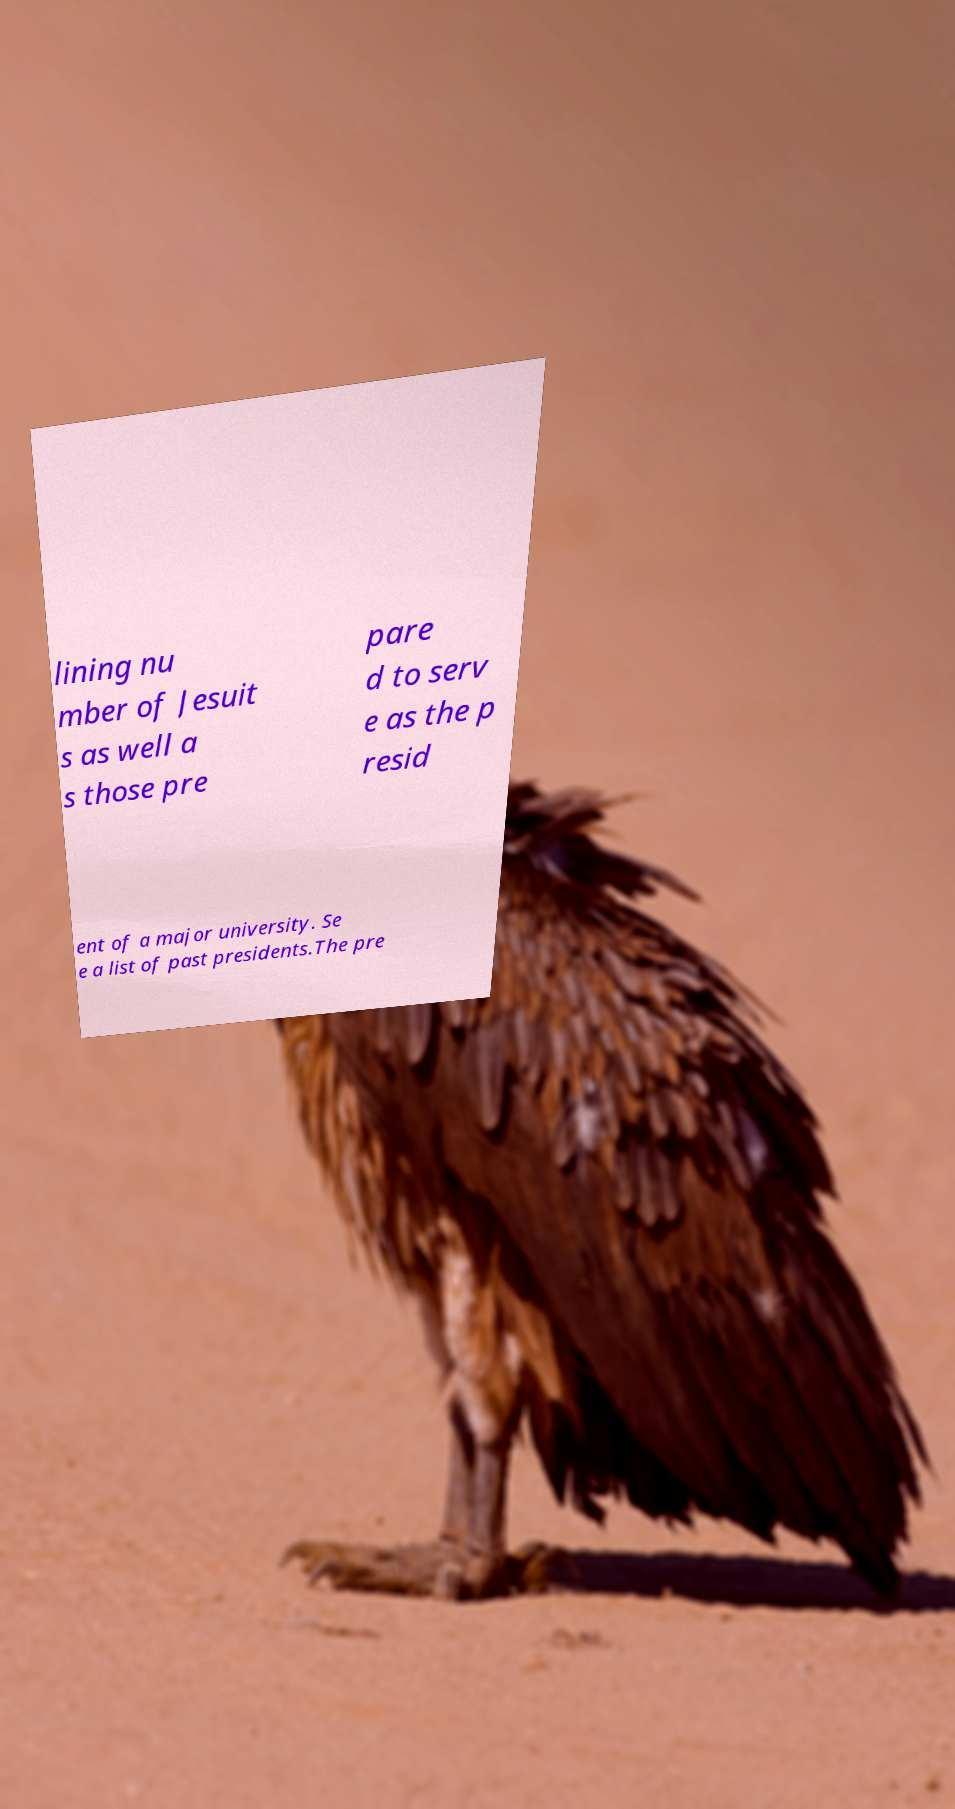Please read and relay the text visible in this image. What does it say? lining nu mber of Jesuit s as well a s those pre pare d to serv e as the p resid ent of a major university. Se e a list of past presidents.The pre 